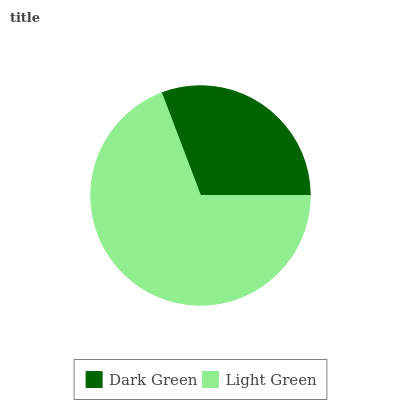Is Dark Green the minimum?
Answer yes or no. Yes. Is Light Green the maximum?
Answer yes or no. Yes. Is Light Green the minimum?
Answer yes or no. No. Is Light Green greater than Dark Green?
Answer yes or no. Yes. Is Dark Green less than Light Green?
Answer yes or no. Yes. Is Dark Green greater than Light Green?
Answer yes or no. No. Is Light Green less than Dark Green?
Answer yes or no. No. Is Light Green the high median?
Answer yes or no. Yes. Is Dark Green the low median?
Answer yes or no. Yes. Is Dark Green the high median?
Answer yes or no. No. Is Light Green the low median?
Answer yes or no. No. 